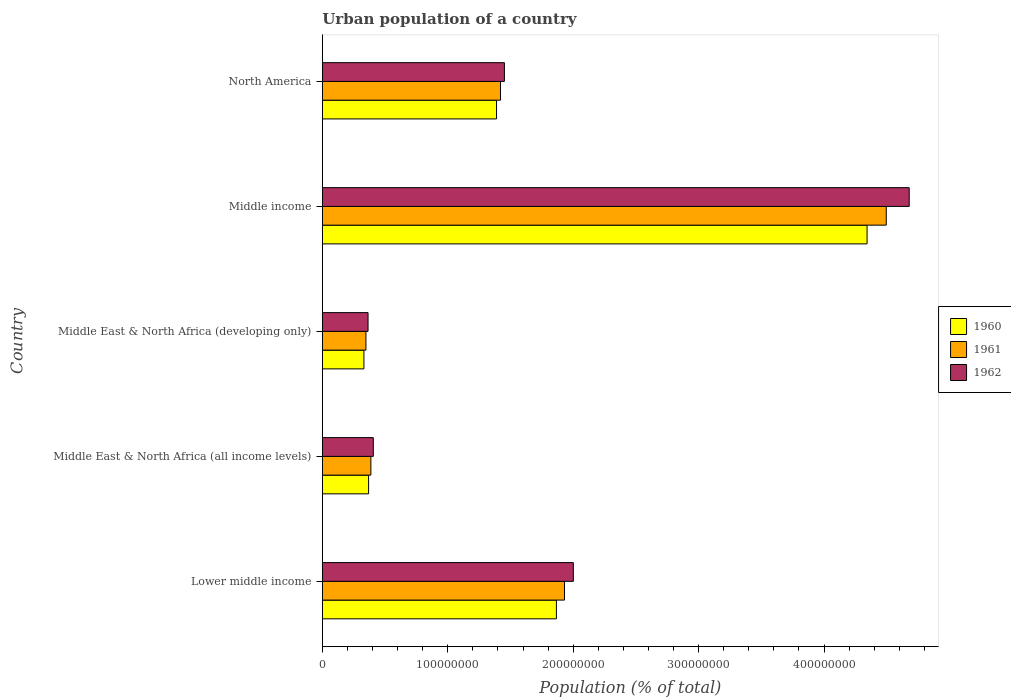How many groups of bars are there?
Your answer should be very brief. 5. Are the number of bars per tick equal to the number of legend labels?
Your response must be concise. Yes. How many bars are there on the 4th tick from the top?
Keep it short and to the point. 3. What is the label of the 5th group of bars from the top?
Ensure brevity in your answer.  Lower middle income. In how many cases, is the number of bars for a given country not equal to the number of legend labels?
Your answer should be compact. 0. What is the urban population in 1960 in North America?
Keep it short and to the point. 1.39e+08. Across all countries, what is the maximum urban population in 1960?
Make the answer very short. 4.34e+08. Across all countries, what is the minimum urban population in 1962?
Your response must be concise. 3.64e+07. In which country was the urban population in 1961 maximum?
Offer a terse response. Middle income. In which country was the urban population in 1962 minimum?
Your answer should be very brief. Middle East & North Africa (developing only). What is the total urban population in 1960 in the graph?
Make the answer very short. 8.30e+08. What is the difference between the urban population in 1962 in Middle East & North Africa (all income levels) and that in North America?
Provide a succinct answer. -1.05e+08. What is the difference between the urban population in 1960 in Middle income and the urban population in 1961 in Lower middle income?
Make the answer very short. 2.41e+08. What is the average urban population in 1962 per country?
Offer a terse response. 1.78e+08. What is the difference between the urban population in 1961 and urban population in 1962 in Lower middle income?
Provide a short and direct response. -7.04e+06. What is the ratio of the urban population in 1960 in Lower middle income to that in Middle East & North Africa (all income levels)?
Provide a succinct answer. 5.06. Is the urban population in 1962 in Lower middle income less than that in Middle East & North Africa (all income levels)?
Your answer should be very brief. No. Is the difference between the urban population in 1961 in Middle East & North Africa (all income levels) and Middle East & North Africa (developing only) greater than the difference between the urban population in 1962 in Middle East & North Africa (all income levels) and Middle East & North Africa (developing only)?
Keep it short and to the point. No. What is the difference between the highest and the second highest urban population in 1962?
Give a very brief answer. 2.68e+08. What is the difference between the highest and the lowest urban population in 1960?
Your response must be concise. 4.01e+08. In how many countries, is the urban population in 1962 greater than the average urban population in 1962 taken over all countries?
Provide a short and direct response. 2. What does the 3rd bar from the bottom in North America represents?
Provide a short and direct response. 1962. Are all the bars in the graph horizontal?
Offer a very short reply. Yes. How many countries are there in the graph?
Your answer should be very brief. 5. What is the difference between two consecutive major ticks on the X-axis?
Your answer should be very brief. 1.00e+08. Are the values on the major ticks of X-axis written in scientific E-notation?
Your answer should be compact. No. Does the graph contain any zero values?
Make the answer very short. No. How are the legend labels stacked?
Ensure brevity in your answer.  Vertical. What is the title of the graph?
Keep it short and to the point. Urban population of a country. What is the label or title of the X-axis?
Provide a succinct answer. Population (% of total). What is the label or title of the Y-axis?
Your response must be concise. Country. What is the Population (% of total) in 1960 in Lower middle income?
Give a very brief answer. 1.87e+08. What is the Population (% of total) of 1961 in Lower middle income?
Make the answer very short. 1.93e+08. What is the Population (% of total) in 1962 in Lower middle income?
Offer a very short reply. 2.00e+08. What is the Population (% of total) in 1960 in Middle East & North Africa (all income levels)?
Your response must be concise. 3.69e+07. What is the Population (% of total) of 1961 in Middle East & North Africa (all income levels)?
Ensure brevity in your answer.  3.87e+07. What is the Population (% of total) in 1962 in Middle East & North Africa (all income levels)?
Your answer should be very brief. 4.06e+07. What is the Population (% of total) in 1960 in Middle East & North Africa (developing only)?
Offer a very short reply. 3.32e+07. What is the Population (% of total) of 1961 in Middle East & North Africa (developing only)?
Offer a very short reply. 3.48e+07. What is the Population (% of total) of 1962 in Middle East & North Africa (developing only)?
Make the answer very short. 3.64e+07. What is the Population (% of total) in 1960 in Middle income?
Provide a short and direct response. 4.34e+08. What is the Population (% of total) of 1961 in Middle income?
Make the answer very short. 4.50e+08. What is the Population (% of total) of 1962 in Middle income?
Offer a terse response. 4.68e+08. What is the Population (% of total) of 1960 in North America?
Provide a succinct answer. 1.39e+08. What is the Population (% of total) in 1961 in North America?
Your answer should be very brief. 1.42e+08. What is the Population (% of total) in 1962 in North America?
Offer a terse response. 1.45e+08. Across all countries, what is the maximum Population (% of total) in 1960?
Make the answer very short. 4.34e+08. Across all countries, what is the maximum Population (% of total) of 1961?
Give a very brief answer. 4.50e+08. Across all countries, what is the maximum Population (% of total) in 1962?
Provide a succinct answer. 4.68e+08. Across all countries, what is the minimum Population (% of total) of 1960?
Give a very brief answer. 3.32e+07. Across all countries, what is the minimum Population (% of total) of 1961?
Ensure brevity in your answer.  3.48e+07. Across all countries, what is the minimum Population (% of total) of 1962?
Make the answer very short. 3.64e+07. What is the total Population (% of total) of 1960 in the graph?
Offer a very short reply. 8.30e+08. What is the total Population (% of total) in 1961 in the graph?
Your response must be concise. 8.58e+08. What is the total Population (% of total) in 1962 in the graph?
Offer a very short reply. 8.90e+08. What is the difference between the Population (% of total) in 1960 in Lower middle income and that in Middle East & North Africa (all income levels)?
Offer a terse response. 1.50e+08. What is the difference between the Population (% of total) in 1961 in Lower middle income and that in Middle East & North Africa (all income levels)?
Give a very brief answer. 1.54e+08. What is the difference between the Population (% of total) of 1962 in Lower middle income and that in Middle East & North Africa (all income levels)?
Your response must be concise. 1.59e+08. What is the difference between the Population (% of total) in 1960 in Lower middle income and that in Middle East & North Africa (developing only)?
Ensure brevity in your answer.  1.53e+08. What is the difference between the Population (% of total) of 1961 in Lower middle income and that in Middle East & North Africa (developing only)?
Keep it short and to the point. 1.58e+08. What is the difference between the Population (% of total) in 1962 in Lower middle income and that in Middle East & North Africa (developing only)?
Provide a short and direct response. 1.64e+08. What is the difference between the Population (% of total) in 1960 in Lower middle income and that in Middle income?
Make the answer very short. -2.48e+08. What is the difference between the Population (% of total) of 1961 in Lower middle income and that in Middle income?
Provide a succinct answer. -2.57e+08. What is the difference between the Population (% of total) of 1962 in Lower middle income and that in Middle income?
Keep it short and to the point. -2.68e+08. What is the difference between the Population (% of total) of 1960 in Lower middle income and that in North America?
Keep it short and to the point. 4.77e+07. What is the difference between the Population (% of total) in 1961 in Lower middle income and that in North America?
Your response must be concise. 5.10e+07. What is the difference between the Population (% of total) of 1962 in Lower middle income and that in North America?
Your answer should be very brief. 5.49e+07. What is the difference between the Population (% of total) of 1960 in Middle East & North Africa (all income levels) and that in Middle East & North Africa (developing only)?
Give a very brief answer. 3.72e+06. What is the difference between the Population (% of total) of 1961 in Middle East & North Africa (all income levels) and that in Middle East & North Africa (developing only)?
Provide a succinct answer. 3.94e+06. What is the difference between the Population (% of total) in 1962 in Middle East & North Africa (all income levels) and that in Middle East & North Africa (developing only)?
Your response must be concise. 4.20e+06. What is the difference between the Population (% of total) of 1960 in Middle East & North Africa (all income levels) and that in Middle income?
Your answer should be compact. -3.97e+08. What is the difference between the Population (% of total) of 1961 in Middle East & North Africa (all income levels) and that in Middle income?
Offer a very short reply. -4.11e+08. What is the difference between the Population (% of total) in 1962 in Middle East & North Africa (all income levels) and that in Middle income?
Offer a very short reply. -4.27e+08. What is the difference between the Population (% of total) of 1960 in Middle East & North Africa (all income levels) and that in North America?
Provide a short and direct response. -1.02e+08. What is the difference between the Population (% of total) of 1961 in Middle East & North Africa (all income levels) and that in North America?
Offer a very short reply. -1.03e+08. What is the difference between the Population (% of total) of 1962 in Middle East & North Africa (all income levels) and that in North America?
Keep it short and to the point. -1.05e+08. What is the difference between the Population (% of total) in 1960 in Middle East & North Africa (developing only) and that in Middle income?
Your answer should be very brief. -4.01e+08. What is the difference between the Population (% of total) in 1961 in Middle East & North Africa (developing only) and that in Middle income?
Ensure brevity in your answer.  -4.15e+08. What is the difference between the Population (% of total) in 1962 in Middle East & North Africa (developing only) and that in Middle income?
Your answer should be compact. -4.31e+08. What is the difference between the Population (% of total) in 1960 in Middle East & North Africa (developing only) and that in North America?
Your answer should be compact. -1.06e+08. What is the difference between the Population (% of total) of 1961 in Middle East & North Africa (developing only) and that in North America?
Keep it short and to the point. -1.07e+08. What is the difference between the Population (% of total) in 1962 in Middle East & North Africa (developing only) and that in North America?
Keep it short and to the point. -1.09e+08. What is the difference between the Population (% of total) in 1960 in Middle income and that in North America?
Make the answer very short. 2.95e+08. What is the difference between the Population (% of total) of 1961 in Middle income and that in North America?
Offer a terse response. 3.08e+08. What is the difference between the Population (% of total) of 1962 in Middle income and that in North America?
Your response must be concise. 3.23e+08. What is the difference between the Population (% of total) in 1960 in Lower middle income and the Population (% of total) in 1961 in Middle East & North Africa (all income levels)?
Your answer should be compact. 1.48e+08. What is the difference between the Population (% of total) of 1960 in Lower middle income and the Population (% of total) of 1962 in Middle East & North Africa (all income levels)?
Give a very brief answer. 1.46e+08. What is the difference between the Population (% of total) of 1961 in Lower middle income and the Population (% of total) of 1962 in Middle East & North Africa (all income levels)?
Your response must be concise. 1.52e+08. What is the difference between the Population (% of total) in 1960 in Lower middle income and the Population (% of total) in 1961 in Middle East & North Africa (developing only)?
Ensure brevity in your answer.  1.52e+08. What is the difference between the Population (% of total) in 1960 in Lower middle income and the Population (% of total) in 1962 in Middle East & North Africa (developing only)?
Offer a very short reply. 1.50e+08. What is the difference between the Population (% of total) of 1961 in Lower middle income and the Population (% of total) of 1962 in Middle East & North Africa (developing only)?
Keep it short and to the point. 1.57e+08. What is the difference between the Population (% of total) in 1960 in Lower middle income and the Population (% of total) in 1961 in Middle income?
Keep it short and to the point. -2.63e+08. What is the difference between the Population (% of total) in 1960 in Lower middle income and the Population (% of total) in 1962 in Middle income?
Provide a short and direct response. -2.81e+08. What is the difference between the Population (% of total) of 1961 in Lower middle income and the Population (% of total) of 1962 in Middle income?
Give a very brief answer. -2.75e+08. What is the difference between the Population (% of total) in 1960 in Lower middle income and the Population (% of total) in 1961 in North America?
Ensure brevity in your answer.  4.46e+07. What is the difference between the Population (% of total) in 1960 in Lower middle income and the Population (% of total) in 1962 in North America?
Make the answer very short. 4.15e+07. What is the difference between the Population (% of total) of 1961 in Lower middle income and the Population (% of total) of 1962 in North America?
Give a very brief answer. 4.79e+07. What is the difference between the Population (% of total) of 1960 in Middle East & North Africa (all income levels) and the Population (% of total) of 1961 in Middle East & North Africa (developing only)?
Ensure brevity in your answer.  2.12e+06. What is the difference between the Population (% of total) of 1960 in Middle East & North Africa (all income levels) and the Population (% of total) of 1962 in Middle East & North Africa (developing only)?
Give a very brief answer. 4.36e+05. What is the difference between the Population (% of total) of 1961 in Middle East & North Africa (all income levels) and the Population (% of total) of 1962 in Middle East & North Africa (developing only)?
Your answer should be very brief. 2.26e+06. What is the difference between the Population (% of total) of 1960 in Middle East & North Africa (all income levels) and the Population (% of total) of 1961 in Middle income?
Provide a short and direct response. -4.13e+08. What is the difference between the Population (% of total) in 1960 in Middle East & North Africa (all income levels) and the Population (% of total) in 1962 in Middle income?
Give a very brief answer. -4.31e+08. What is the difference between the Population (% of total) in 1961 in Middle East & North Africa (all income levels) and the Population (% of total) in 1962 in Middle income?
Provide a short and direct response. -4.29e+08. What is the difference between the Population (% of total) of 1960 in Middle East & North Africa (all income levels) and the Population (% of total) of 1961 in North America?
Keep it short and to the point. -1.05e+08. What is the difference between the Population (% of total) in 1960 in Middle East & North Africa (all income levels) and the Population (% of total) in 1962 in North America?
Your response must be concise. -1.08e+08. What is the difference between the Population (% of total) of 1961 in Middle East & North Africa (all income levels) and the Population (% of total) of 1962 in North America?
Give a very brief answer. -1.06e+08. What is the difference between the Population (% of total) of 1960 in Middle East & North Africa (developing only) and the Population (% of total) of 1961 in Middle income?
Offer a terse response. -4.16e+08. What is the difference between the Population (% of total) of 1960 in Middle East & North Africa (developing only) and the Population (% of total) of 1962 in Middle income?
Your response must be concise. -4.35e+08. What is the difference between the Population (% of total) in 1961 in Middle East & North Africa (developing only) and the Population (% of total) in 1962 in Middle income?
Give a very brief answer. -4.33e+08. What is the difference between the Population (% of total) in 1960 in Middle East & North Africa (developing only) and the Population (% of total) in 1961 in North America?
Your response must be concise. -1.09e+08. What is the difference between the Population (% of total) of 1960 in Middle East & North Africa (developing only) and the Population (% of total) of 1962 in North America?
Keep it short and to the point. -1.12e+08. What is the difference between the Population (% of total) in 1961 in Middle East & North Africa (developing only) and the Population (% of total) in 1962 in North America?
Ensure brevity in your answer.  -1.10e+08. What is the difference between the Population (% of total) in 1960 in Middle income and the Population (% of total) in 1961 in North America?
Give a very brief answer. 2.92e+08. What is the difference between the Population (% of total) of 1960 in Middle income and the Population (% of total) of 1962 in North America?
Your answer should be very brief. 2.89e+08. What is the difference between the Population (% of total) of 1961 in Middle income and the Population (% of total) of 1962 in North America?
Make the answer very short. 3.04e+08. What is the average Population (% of total) in 1960 per country?
Your answer should be compact. 1.66e+08. What is the average Population (% of total) in 1961 per country?
Offer a very short reply. 1.72e+08. What is the average Population (% of total) in 1962 per country?
Make the answer very short. 1.78e+08. What is the difference between the Population (% of total) of 1960 and Population (% of total) of 1961 in Lower middle income?
Offer a terse response. -6.46e+06. What is the difference between the Population (% of total) of 1960 and Population (% of total) of 1962 in Lower middle income?
Offer a terse response. -1.35e+07. What is the difference between the Population (% of total) of 1961 and Population (% of total) of 1962 in Lower middle income?
Provide a succinct answer. -7.04e+06. What is the difference between the Population (% of total) of 1960 and Population (% of total) of 1961 in Middle East & North Africa (all income levels)?
Keep it short and to the point. -1.83e+06. What is the difference between the Population (% of total) in 1960 and Population (% of total) in 1962 in Middle East & North Africa (all income levels)?
Offer a very short reply. -3.76e+06. What is the difference between the Population (% of total) in 1961 and Population (% of total) in 1962 in Middle East & North Africa (all income levels)?
Your answer should be compact. -1.94e+06. What is the difference between the Population (% of total) in 1960 and Population (% of total) in 1961 in Middle East & North Africa (developing only)?
Provide a succinct answer. -1.61e+06. What is the difference between the Population (% of total) of 1960 and Population (% of total) of 1962 in Middle East & North Africa (developing only)?
Offer a very short reply. -3.29e+06. What is the difference between the Population (% of total) in 1961 and Population (% of total) in 1962 in Middle East & North Africa (developing only)?
Provide a short and direct response. -1.68e+06. What is the difference between the Population (% of total) in 1960 and Population (% of total) in 1961 in Middle income?
Make the answer very short. -1.53e+07. What is the difference between the Population (% of total) of 1960 and Population (% of total) of 1962 in Middle income?
Give a very brief answer. -3.36e+07. What is the difference between the Population (% of total) of 1961 and Population (% of total) of 1962 in Middle income?
Offer a terse response. -1.83e+07. What is the difference between the Population (% of total) of 1960 and Population (% of total) of 1961 in North America?
Give a very brief answer. -3.18e+06. What is the difference between the Population (% of total) in 1960 and Population (% of total) in 1962 in North America?
Provide a short and direct response. -6.28e+06. What is the difference between the Population (% of total) in 1961 and Population (% of total) in 1962 in North America?
Give a very brief answer. -3.11e+06. What is the ratio of the Population (% of total) in 1960 in Lower middle income to that in Middle East & North Africa (all income levels)?
Your response must be concise. 5.06. What is the ratio of the Population (% of total) of 1961 in Lower middle income to that in Middle East & North Africa (all income levels)?
Offer a terse response. 4.99. What is the ratio of the Population (% of total) in 1962 in Lower middle income to that in Middle East & North Africa (all income levels)?
Give a very brief answer. 4.92. What is the ratio of the Population (% of total) of 1960 in Lower middle income to that in Middle East & North Africa (developing only)?
Offer a terse response. 5.63. What is the ratio of the Population (% of total) of 1961 in Lower middle income to that in Middle East & North Africa (developing only)?
Provide a short and direct response. 5.55. What is the ratio of the Population (% of total) in 1962 in Lower middle income to that in Middle East & North Africa (developing only)?
Offer a very short reply. 5.49. What is the ratio of the Population (% of total) of 1960 in Lower middle income to that in Middle income?
Offer a very short reply. 0.43. What is the ratio of the Population (% of total) of 1961 in Lower middle income to that in Middle income?
Ensure brevity in your answer.  0.43. What is the ratio of the Population (% of total) of 1962 in Lower middle income to that in Middle income?
Your response must be concise. 0.43. What is the ratio of the Population (% of total) in 1960 in Lower middle income to that in North America?
Provide a succinct answer. 1.34. What is the ratio of the Population (% of total) of 1961 in Lower middle income to that in North America?
Offer a terse response. 1.36. What is the ratio of the Population (% of total) in 1962 in Lower middle income to that in North America?
Provide a short and direct response. 1.38. What is the ratio of the Population (% of total) in 1960 in Middle East & North Africa (all income levels) to that in Middle East & North Africa (developing only)?
Your answer should be very brief. 1.11. What is the ratio of the Population (% of total) in 1961 in Middle East & North Africa (all income levels) to that in Middle East & North Africa (developing only)?
Offer a very short reply. 1.11. What is the ratio of the Population (% of total) in 1962 in Middle East & North Africa (all income levels) to that in Middle East & North Africa (developing only)?
Your answer should be very brief. 1.12. What is the ratio of the Population (% of total) of 1960 in Middle East & North Africa (all income levels) to that in Middle income?
Your answer should be compact. 0.08. What is the ratio of the Population (% of total) of 1961 in Middle East & North Africa (all income levels) to that in Middle income?
Offer a terse response. 0.09. What is the ratio of the Population (% of total) of 1962 in Middle East & North Africa (all income levels) to that in Middle income?
Make the answer very short. 0.09. What is the ratio of the Population (% of total) in 1960 in Middle East & North Africa (all income levels) to that in North America?
Your answer should be compact. 0.27. What is the ratio of the Population (% of total) in 1961 in Middle East & North Africa (all income levels) to that in North America?
Provide a short and direct response. 0.27. What is the ratio of the Population (% of total) in 1962 in Middle East & North Africa (all income levels) to that in North America?
Offer a terse response. 0.28. What is the ratio of the Population (% of total) in 1960 in Middle East & North Africa (developing only) to that in Middle income?
Keep it short and to the point. 0.08. What is the ratio of the Population (% of total) of 1961 in Middle East & North Africa (developing only) to that in Middle income?
Your answer should be compact. 0.08. What is the ratio of the Population (% of total) of 1962 in Middle East & North Africa (developing only) to that in Middle income?
Provide a succinct answer. 0.08. What is the ratio of the Population (% of total) in 1960 in Middle East & North Africa (developing only) to that in North America?
Offer a terse response. 0.24. What is the ratio of the Population (% of total) in 1961 in Middle East & North Africa (developing only) to that in North America?
Offer a terse response. 0.24. What is the ratio of the Population (% of total) in 1962 in Middle East & North Africa (developing only) to that in North America?
Make the answer very short. 0.25. What is the ratio of the Population (% of total) of 1960 in Middle income to that in North America?
Provide a short and direct response. 3.13. What is the ratio of the Population (% of total) in 1961 in Middle income to that in North America?
Give a very brief answer. 3.17. What is the ratio of the Population (% of total) of 1962 in Middle income to that in North America?
Provide a succinct answer. 3.22. What is the difference between the highest and the second highest Population (% of total) in 1960?
Your answer should be compact. 2.48e+08. What is the difference between the highest and the second highest Population (% of total) of 1961?
Offer a very short reply. 2.57e+08. What is the difference between the highest and the second highest Population (% of total) in 1962?
Make the answer very short. 2.68e+08. What is the difference between the highest and the lowest Population (% of total) of 1960?
Your response must be concise. 4.01e+08. What is the difference between the highest and the lowest Population (% of total) in 1961?
Your response must be concise. 4.15e+08. What is the difference between the highest and the lowest Population (% of total) of 1962?
Make the answer very short. 4.31e+08. 